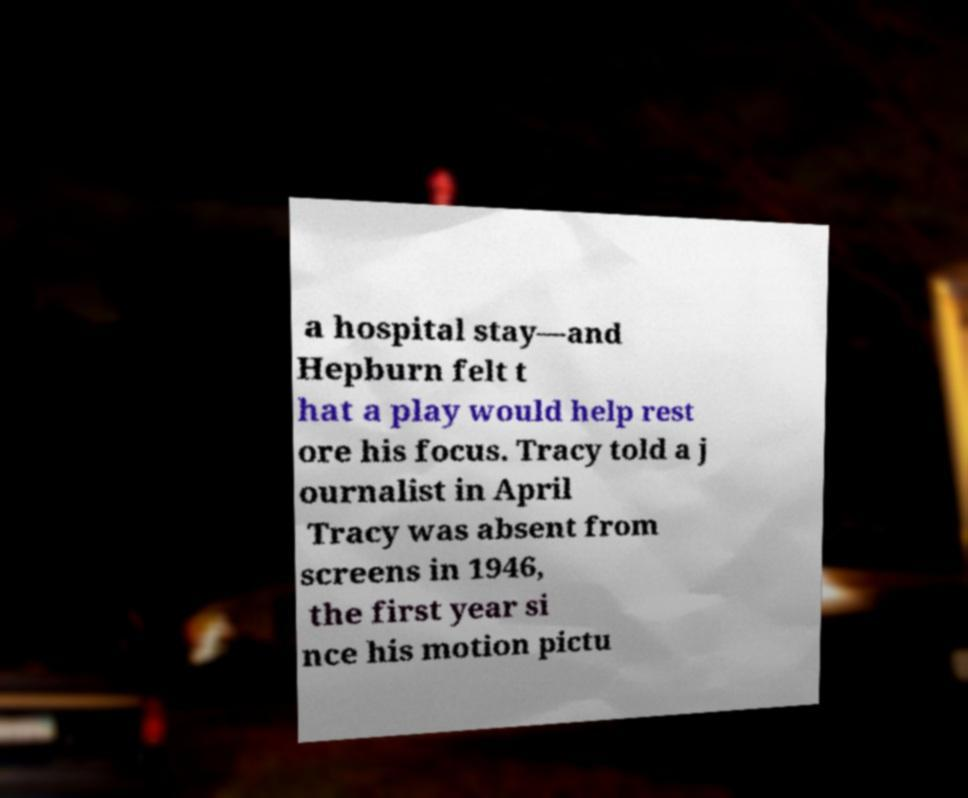What messages or text are displayed in this image? I need them in a readable, typed format. a hospital stay—and Hepburn felt t hat a play would help rest ore his focus. Tracy told a j ournalist in April Tracy was absent from screens in 1946, the first year si nce his motion pictu 